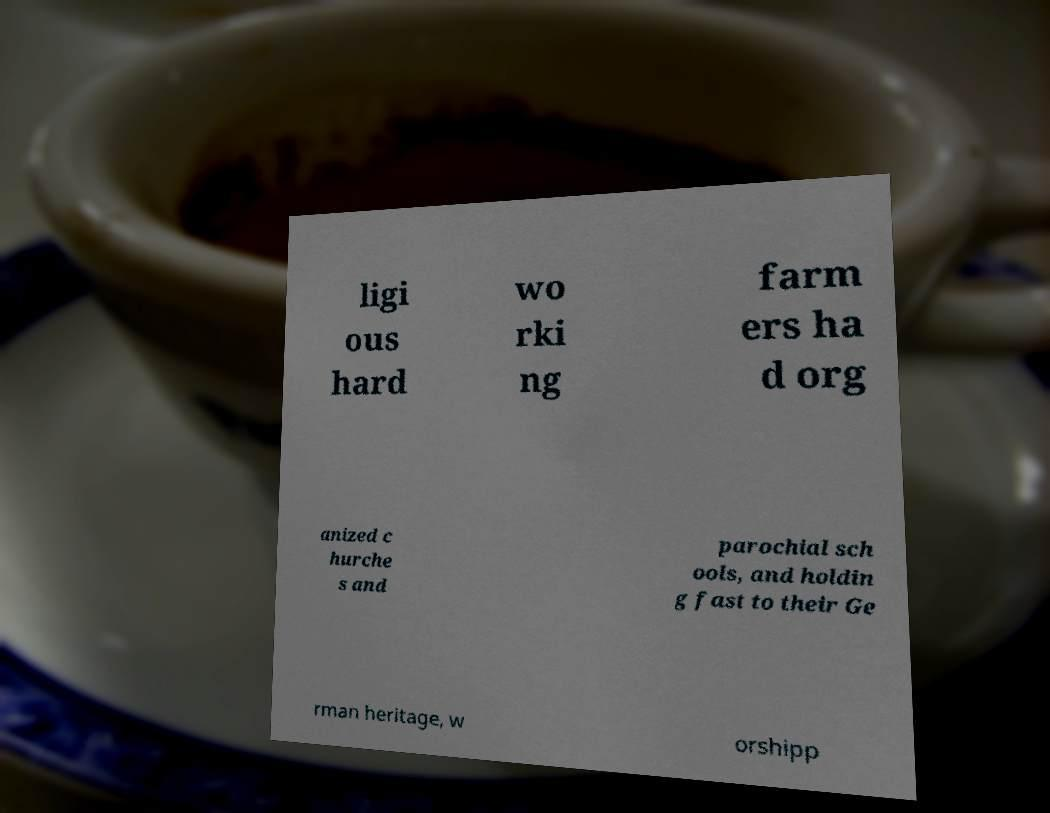I need the written content from this picture converted into text. Can you do that? ligi ous hard wo rki ng farm ers ha d org anized c hurche s and parochial sch ools, and holdin g fast to their Ge rman heritage, w orshipp 